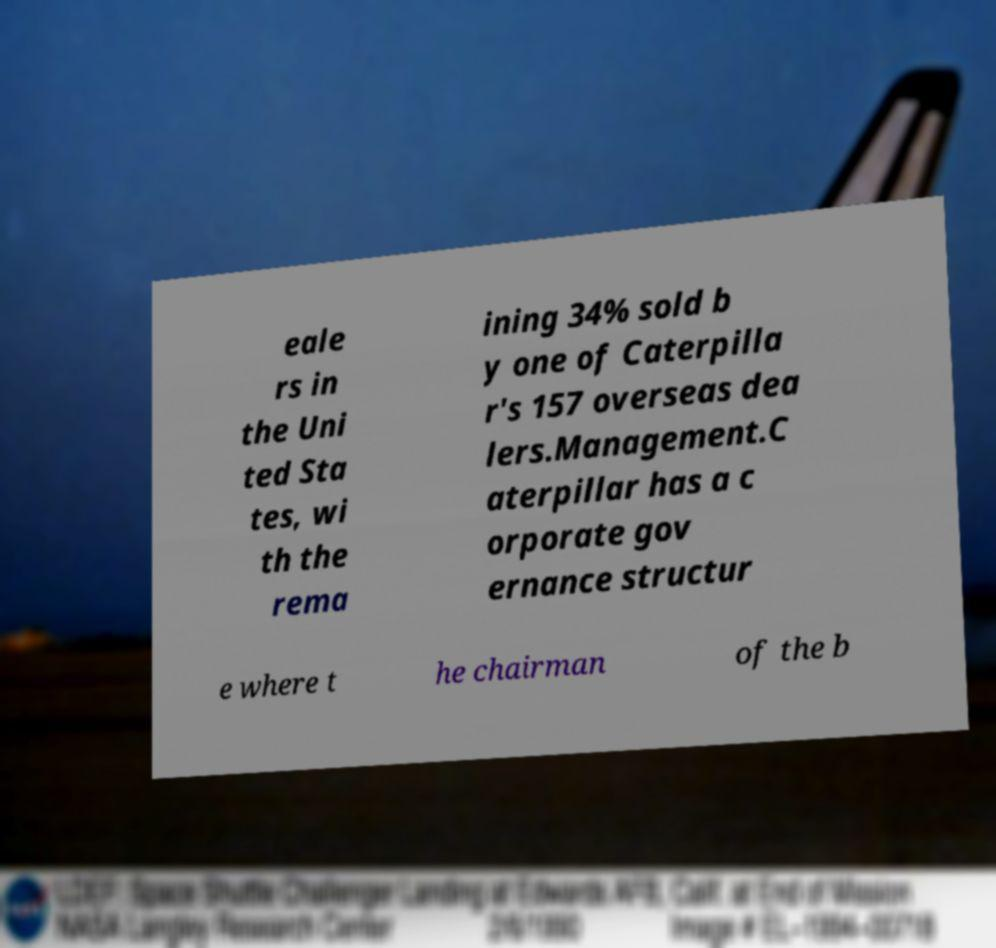There's text embedded in this image that I need extracted. Can you transcribe it verbatim? eale rs in the Uni ted Sta tes, wi th the rema ining 34% sold b y one of Caterpilla r's 157 overseas dea lers.Management.C aterpillar has a c orporate gov ernance structur e where t he chairman of the b 